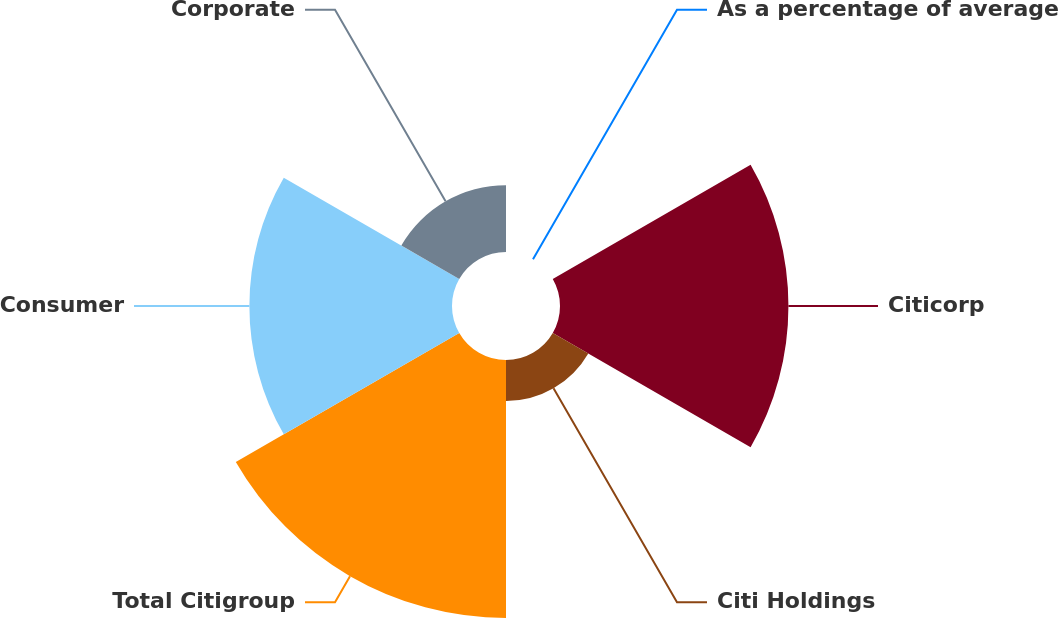Convert chart to OTSL. <chart><loc_0><loc_0><loc_500><loc_500><pie_chart><fcel>As a percentage of average<fcel>Citicorp<fcel>Citi Holdings<fcel>Total Citigroup<fcel>Consumer<fcel>Corporate<nl><fcel>0.0%<fcel>28.66%<fcel>5.15%<fcel>32.37%<fcel>25.42%<fcel>8.39%<nl></chart> 